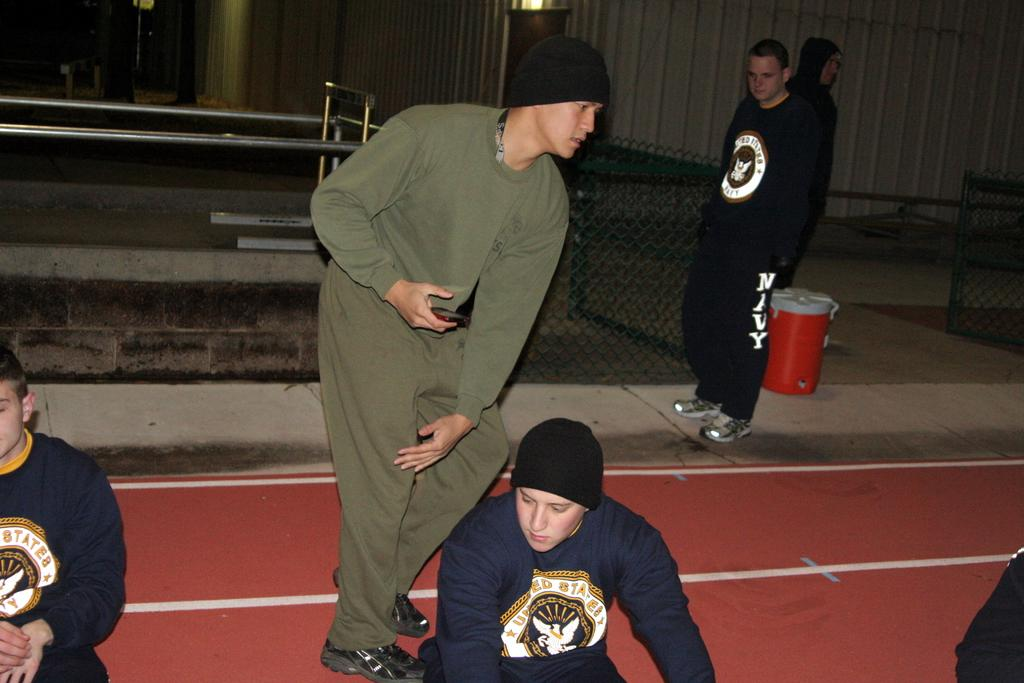<image>
Summarize the visual content of the image. Several men are around a track, one is wearing sweatpants that say Navy on them. 